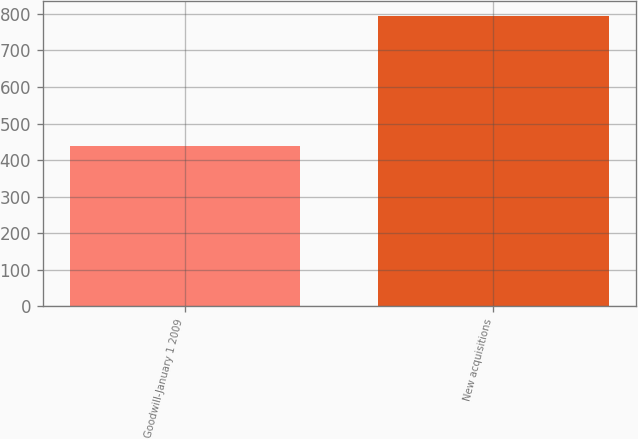Convert chart. <chart><loc_0><loc_0><loc_500><loc_500><bar_chart><fcel>Goodwill-January 1 2009<fcel>New acquisitions<nl><fcel>438<fcel>794<nl></chart> 